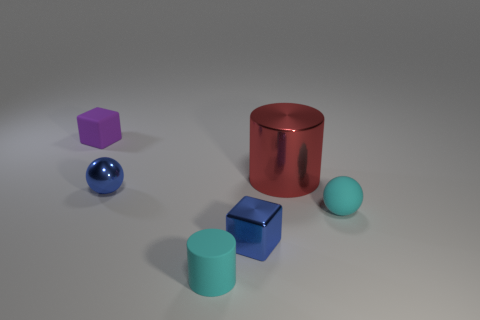Add 4 cyan cylinders. How many objects exist? 10 Subtract 2 blocks. How many blocks are left? 0 Subtract all cyan cylinders. Subtract all cyan blocks. How many cylinders are left? 1 Subtract all blue cylinders. How many cyan blocks are left? 0 Subtract all large shiny objects. Subtract all purple objects. How many objects are left? 4 Add 5 large red metal cylinders. How many large red metal cylinders are left? 6 Add 6 small blue things. How many small blue things exist? 8 Subtract all purple cubes. How many cubes are left? 1 Subtract 0 gray cubes. How many objects are left? 6 Subtract all blocks. How many objects are left? 4 